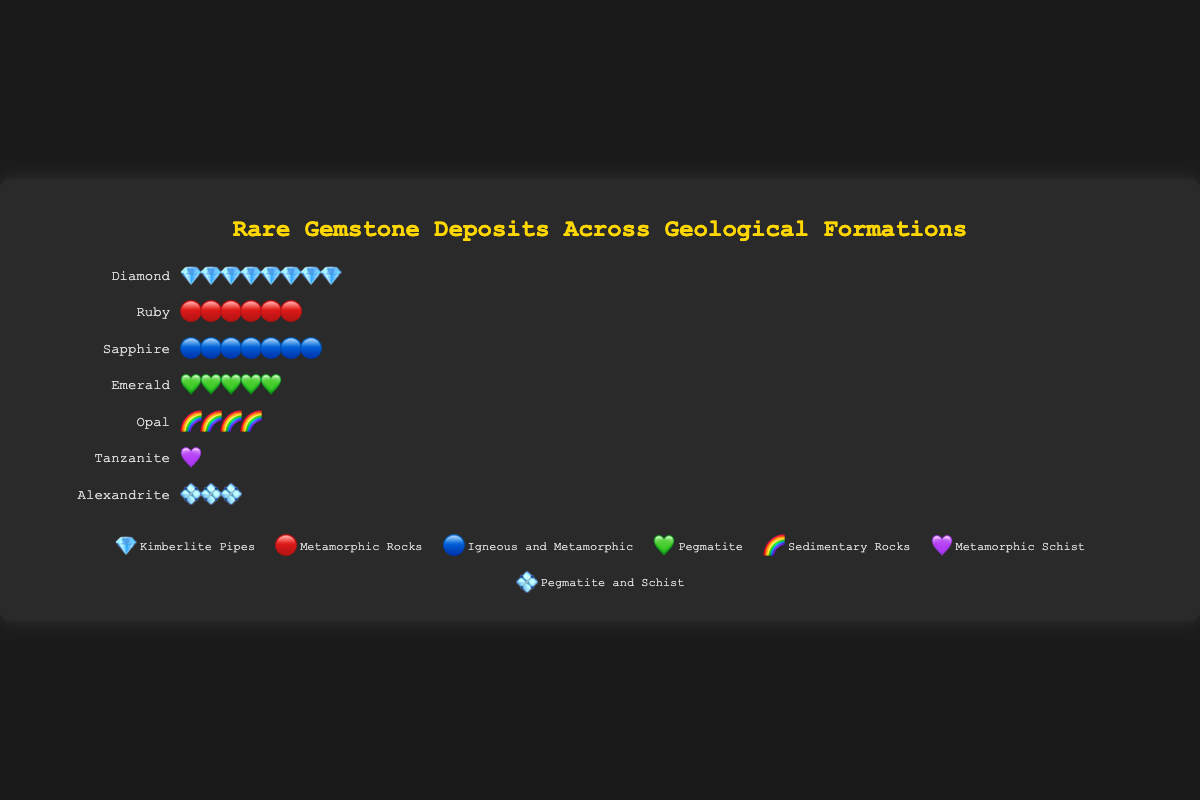Which gemstone has the most locations worldwide? To find the gemstone with the most locations, look at the row with the largest number of icons in the chart.
Answer: Diamond What geological formation is associated with emerald deposits? Find the row labeled "Emerald" and check the legend to see what the icon (💚) corresponds to.
Answer: Pegmatite How many gemstones have more than 5 locations? Count the number of gemstones with more than 5 icons in their row.
Answer: 3 Which gemstone has the fewest locations? Look for the row with the least number of icons.
Answer: Tanzanite Compare the number of locations for Ruby and Sapphire. Which has more? Count the number of icons in the rows labeled "Ruby" and "Sapphire" respectively. Ruby has 6 icons and Sapphire has 7 icons.
Answer: Sapphire What is the total number of locations for all gemstones combined? Sum the number of locations for each gemstone: 8 (Diamond) + 6 (Ruby) + 7 (Sapphire) + 5 (Emerald) + 4 (Opal) + 1 (Tanzanite) + 3 (Alexandrite) = 34.
Answer: 34 Which formations have more than one gemstone associated with them? Check the legend for formations that appear more than once among the gemstones: Pegmatite (Emerald, Alexandrite), Metamorphic Rocks (Ruby, Tanzanite).
Answer: Pegmatite, Metamorphic Rocks If an additional 2 deposits are discovered for Tanzanite, how does this affect its ranking in terms of location count? Adding 2 to Tanzanite's current locations (1) gives it 3. This matches Alexandrite's count, so it would still have the fewest locations but would be tied with Alexandrite.
Answer: It would be tied with Alexandrite for the least locations 